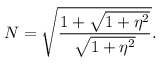<formula> <loc_0><loc_0><loc_500><loc_500>N = \sqrt { \frac { 1 + \sqrt { 1 + \eta ^ { 2 } } } { \sqrt { 1 + \eta ^ { 2 } } } } .</formula> 